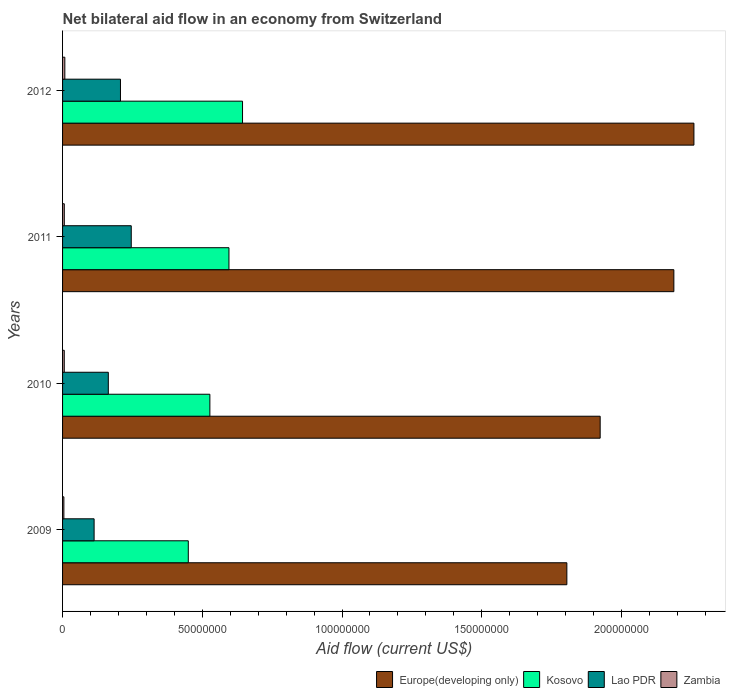How many groups of bars are there?
Your answer should be very brief. 4. Are the number of bars per tick equal to the number of legend labels?
Provide a short and direct response. Yes. How many bars are there on the 4th tick from the top?
Your response must be concise. 4. In how many cases, is the number of bars for a given year not equal to the number of legend labels?
Offer a terse response. 0. What is the net bilateral aid flow in Lao PDR in 2012?
Make the answer very short. 2.07e+07. Across all years, what is the maximum net bilateral aid flow in Europe(developing only)?
Give a very brief answer. 2.26e+08. Across all years, what is the minimum net bilateral aid flow in Zambia?
Provide a short and direct response. 4.70e+05. In which year was the net bilateral aid flow in Lao PDR maximum?
Your answer should be compact. 2011. In which year was the net bilateral aid flow in Europe(developing only) minimum?
Give a very brief answer. 2009. What is the total net bilateral aid flow in Lao PDR in the graph?
Make the answer very short. 7.30e+07. What is the difference between the net bilateral aid flow in Zambia in 2009 and that in 2010?
Ensure brevity in your answer.  -1.40e+05. What is the difference between the net bilateral aid flow in Lao PDR in 2009 and the net bilateral aid flow in Kosovo in 2012?
Provide a short and direct response. -5.31e+07. What is the average net bilateral aid flow in Kosovo per year?
Offer a very short reply. 5.54e+07. In the year 2010, what is the difference between the net bilateral aid flow in Kosovo and net bilateral aid flow in Zambia?
Keep it short and to the point. 5.21e+07. In how many years, is the net bilateral aid flow in Zambia greater than 60000000 US$?
Your answer should be very brief. 0. What is the ratio of the net bilateral aid flow in Zambia in 2009 to that in 2012?
Ensure brevity in your answer.  0.58. What is the difference between the highest and the second highest net bilateral aid flow in Zambia?
Your response must be concise. 1.90e+05. What is the difference between the highest and the lowest net bilateral aid flow in Europe(developing only)?
Ensure brevity in your answer.  4.55e+07. What does the 1st bar from the top in 2012 represents?
Provide a succinct answer. Zambia. What does the 1st bar from the bottom in 2012 represents?
Provide a short and direct response. Europe(developing only). How many years are there in the graph?
Offer a terse response. 4. Are the values on the major ticks of X-axis written in scientific E-notation?
Ensure brevity in your answer.  No. Does the graph contain grids?
Make the answer very short. No. Where does the legend appear in the graph?
Ensure brevity in your answer.  Bottom right. How many legend labels are there?
Provide a short and direct response. 4. How are the legend labels stacked?
Your response must be concise. Horizontal. What is the title of the graph?
Keep it short and to the point. Net bilateral aid flow in an economy from Switzerland. Does "Comoros" appear as one of the legend labels in the graph?
Ensure brevity in your answer.  No. What is the label or title of the X-axis?
Keep it short and to the point. Aid flow (current US$). What is the label or title of the Y-axis?
Ensure brevity in your answer.  Years. What is the Aid flow (current US$) of Europe(developing only) in 2009?
Provide a succinct answer. 1.80e+08. What is the Aid flow (current US$) in Kosovo in 2009?
Provide a succinct answer. 4.50e+07. What is the Aid flow (current US$) in Lao PDR in 2009?
Ensure brevity in your answer.  1.13e+07. What is the Aid flow (current US$) in Zambia in 2009?
Your answer should be compact. 4.70e+05. What is the Aid flow (current US$) in Europe(developing only) in 2010?
Your response must be concise. 1.92e+08. What is the Aid flow (current US$) in Kosovo in 2010?
Provide a succinct answer. 5.27e+07. What is the Aid flow (current US$) in Lao PDR in 2010?
Your answer should be compact. 1.64e+07. What is the Aid flow (current US$) of Zambia in 2010?
Your answer should be compact. 6.10e+05. What is the Aid flow (current US$) in Europe(developing only) in 2011?
Provide a short and direct response. 2.19e+08. What is the Aid flow (current US$) of Kosovo in 2011?
Make the answer very short. 5.95e+07. What is the Aid flow (current US$) of Lao PDR in 2011?
Your answer should be very brief. 2.46e+07. What is the Aid flow (current US$) of Zambia in 2011?
Make the answer very short. 6.20e+05. What is the Aid flow (current US$) of Europe(developing only) in 2012?
Offer a very short reply. 2.26e+08. What is the Aid flow (current US$) of Kosovo in 2012?
Provide a short and direct response. 6.44e+07. What is the Aid flow (current US$) in Lao PDR in 2012?
Provide a short and direct response. 2.07e+07. What is the Aid flow (current US$) in Zambia in 2012?
Offer a very short reply. 8.10e+05. Across all years, what is the maximum Aid flow (current US$) of Europe(developing only)?
Your response must be concise. 2.26e+08. Across all years, what is the maximum Aid flow (current US$) in Kosovo?
Keep it short and to the point. 6.44e+07. Across all years, what is the maximum Aid flow (current US$) in Lao PDR?
Give a very brief answer. 2.46e+07. Across all years, what is the maximum Aid flow (current US$) of Zambia?
Provide a succinct answer. 8.10e+05. Across all years, what is the minimum Aid flow (current US$) of Europe(developing only)?
Make the answer very short. 1.80e+08. Across all years, what is the minimum Aid flow (current US$) in Kosovo?
Your response must be concise. 4.50e+07. Across all years, what is the minimum Aid flow (current US$) in Lao PDR?
Your answer should be compact. 1.13e+07. Across all years, what is the minimum Aid flow (current US$) of Zambia?
Your answer should be compact. 4.70e+05. What is the total Aid flow (current US$) in Europe(developing only) in the graph?
Your answer should be compact. 8.17e+08. What is the total Aid flow (current US$) of Kosovo in the graph?
Your answer should be very brief. 2.22e+08. What is the total Aid flow (current US$) in Lao PDR in the graph?
Give a very brief answer. 7.30e+07. What is the total Aid flow (current US$) in Zambia in the graph?
Provide a succinct answer. 2.51e+06. What is the difference between the Aid flow (current US$) in Europe(developing only) in 2009 and that in 2010?
Provide a succinct answer. -1.19e+07. What is the difference between the Aid flow (current US$) in Kosovo in 2009 and that in 2010?
Your answer should be very brief. -7.72e+06. What is the difference between the Aid flow (current US$) of Lao PDR in 2009 and that in 2010?
Give a very brief answer. -5.08e+06. What is the difference between the Aid flow (current US$) of Europe(developing only) in 2009 and that in 2011?
Provide a succinct answer. -3.83e+07. What is the difference between the Aid flow (current US$) in Kosovo in 2009 and that in 2011?
Provide a succinct answer. -1.46e+07. What is the difference between the Aid flow (current US$) in Lao PDR in 2009 and that in 2011?
Ensure brevity in your answer.  -1.33e+07. What is the difference between the Aid flow (current US$) of Europe(developing only) in 2009 and that in 2012?
Offer a terse response. -4.55e+07. What is the difference between the Aid flow (current US$) of Kosovo in 2009 and that in 2012?
Give a very brief answer. -1.94e+07. What is the difference between the Aid flow (current US$) in Lao PDR in 2009 and that in 2012?
Offer a terse response. -9.43e+06. What is the difference between the Aid flow (current US$) of Europe(developing only) in 2010 and that in 2011?
Offer a very short reply. -2.64e+07. What is the difference between the Aid flow (current US$) of Kosovo in 2010 and that in 2011?
Provide a succinct answer. -6.83e+06. What is the difference between the Aid flow (current US$) of Lao PDR in 2010 and that in 2011?
Give a very brief answer. -8.21e+06. What is the difference between the Aid flow (current US$) in Europe(developing only) in 2010 and that in 2012?
Offer a terse response. -3.36e+07. What is the difference between the Aid flow (current US$) of Kosovo in 2010 and that in 2012?
Keep it short and to the point. -1.17e+07. What is the difference between the Aid flow (current US$) in Lao PDR in 2010 and that in 2012?
Your answer should be compact. -4.35e+06. What is the difference between the Aid flow (current US$) of Zambia in 2010 and that in 2012?
Offer a very short reply. -2.00e+05. What is the difference between the Aid flow (current US$) in Europe(developing only) in 2011 and that in 2012?
Your answer should be compact. -7.18e+06. What is the difference between the Aid flow (current US$) in Kosovo in 2011 and that in 2012?
Provide a succinct answer. -4.86e+06. What is the difference between the Aid flow (current US$) of Lao PDR in 2011 and that in 2012?
Make the answer very short. 3.86e+06. What is the difference between the Aid flow (current US$) of Europe(developing only) in 2009 and the Aid flow (current US$) of Kosovo in 2010?
Offer a very short reply. 1.28e+08. What is the difference between the Aid flow (current US$) of Europe(developing only) in 2009 and the Aid flow (current US$) of Lao PDR in 2010?
Offer a very short reply. 1.64e+08. What is the difference between the Aid flow (current US$) of Europe(developing only) in 2009 and the Aid flow (current US$) of Zambia in 2010?
Keep it short and to the point. 1.80e+08. What is the difference between the Aid flow (current US$) in Kosovo in 2009 and the Aid flow (current US$) in Lao PDR in 2010?
Your answer should be very brief. 2.86e+07. What is the difference between the Aid flow (current US$) of Kosovo in 2009 and the Aid flow (current US$) of Zambia in 2010?
Your answer should be very brief. 4.44e+07. What is the difference between the Aid flow (current US$) of Lao PDR in 2009 and the Aid flow (current US$) of Zambia in 2010?
Keep it short and to the point. 1.07e+07. What is the difference between the Aid flow (current US$) in Europe(developing only) in 2009 and the Aid flow (current US$) in Kosovo in 2011?
Offer a very short reply. 1.21e+08. What is the difference between the Aid flow (current US$) of Europe(developing only) in 2009 and the Aid flow (current US$) of Lao PDR in 2011?
Ensure brevity in your answer.  1.56e+08. What is the difference between the Aid flow (current US$) in Europe(developing only) in 2009 and the Aid flow (current US$) in Zambia in 2011?
Provide a short and direct response. 1.80e+08. What is the difference between the Aid flow (current US$) of Kosovo in 2009 and the Aid flow (current US$) of Lao PDR in 2011?
Give a very brief answer. 2.04e+07. What is the difference between the Aid flow (current US$) in Kosovo in 2009 and the Aid flow (current US$) in Zambia in 2011?
Give a very brief answer. 4.44e+07. What is the difference between the Aid flow (current US$) in Lao PDR in 2009 and the Aid flow (current US$) in Zambia in 2011?
Ensure brevity in your answer.  1.07e+07. What is the difference between the Aid flow (current US$) in Europe(developing only) in 2009 and the Aid flow (current US$) in Kosovo in 2012?
Ensure brevity in your answer.  1.16e+08. What is the difference between the Aid flow (current US$) of Europe(developing only) in 2009 and the Aid flow (current US$) of Lao PDR in 2012?
Your answer should be compact. 1.60e+08. What is the difference between the Aid flow (current US$) of Europe(developing only) in 2009 and the Aid flow (current US$) of Zambia in 2012?
Provide a short and direct response. 1.80e+08. What is the difference between the Aid flow (current US$) in Kosovo in 2009 and the Aid flow (current US$) in Lao PDR in 2012?
Offer a very short reply. 2.43e+07. What is the difference between the Aid flow (current US$) in Kosovo in 2009 and the Aid flow (current US$) in Zambia in 2012?
Your answer should be compact. 4.42e+07. What is the difference between the Aid flow (current US$) of Lao PDR in 2009 and the Aid flow (current US$) of Zambia in 2012?
Your answer should be very brief. 1.05e+07. What is the difference between the Aid flow (current US$) in Europe(developing only) in 2010 and the Aid flow (current US$) in Kosovo in 2011?
Your answer should be compact. 1.33e+08. What is the difference between the Aid flow (current US$) in Europe(developing only) in 2010 and the Aid flow (current US$) in Lao PDR in 2011?
Keep it short and to the point. 1.68e+08. What is the difference between the Aid flow (current US$) in Europe(developing only) in 2010 and the Aid flow (current US$) in Zambia in 2011?
Provide a succinct answer. 1.92e+08. What is the difference between the Aid flow (current US$) of Kosovo in 2010 and the Aid flow (current US$) of Lao PDR in 2011?
Offer a terse response. 2.81e+07. What is the difference between the Aid flow (current US$) in Kosovo in 2010 and the Aid flow (current US$) in Zambia in 2011?
Provide a succinct answer. 5.21e+07. What is the difference between the Aid flow (current US$) in Lao PDR in 2010 and the Aid flow (current US$) in Zambia in 2011?
Make the answer very short. 1.58e+07. What is the difference between the Aid flow (current US$) in Europe(developing only) in 2010 and the Aid flow (current US$) in Kosovo in 2012?
Ensure brevity in your answer.  1.28e+08. What is the difference between the Aid flow (current US$) of Europe(developing only) in 2010 and the Aid flow (current US$) of Lao PDR in 2012?
Your response must be concise. 1.72e+08. What is the difference between the Aid flow (current US$) of Europe(developing only) in 2010 and the Aid flow (current US$) of Zambia in 2012?
Offer a terse response. 1.92e+08. What is the difference between the Aid flow (current US$) of Kosovo in 2010 and the Aid flow (current US$) of Lao PDR in 2012?
Give a very brief answer. 3.20e+07. What is the difference between the Aid flow (current US$) of Kosovo in 2010 and the Aid flow (current US$) of Zambia in 2012?
Offer a very short reply. 5.19e+07. What is the difference between the Aid flow (current US$) in Lao PDR in 2010 and the Aid flow (current US$) in Zambia in 2012?
Your response must be concise. 1.56e+07. What is the difference between the Aid flow (current US$) in Europe(developing only) in 2011 and the Aid flow (current US$) in Kosovo in 2012?
Your answer should be compact. 1.54e+08. What is the difference between the Aid flow (current US$) of Europe(developing only) in 2011 and the Aid flow (current US$) of Lao PDR in 2012?
Your response must be concise. 1.98e+08. What is the difference between the Aid flow (current US$) of Europe(developing only) in 2011 and the Aid flow (current US$) of Zambia in 2012?
Your response must be concise. 2.18e+08. What is the difference between the Aid flow (current US$) of Kosovo in 2011 and the Aid flow (current US$) of Lao PDR in 2012?
Provide a short and direct response. 3.88e+07. What is the difference between the Aid flow (current US$) in Kosovo in 2011 and the Aid flow (current US$) in Zambia in 2012?
Provide a succinct answer. 5.87e+07. What is the difference between the Aid flow (current US$) of Lao PDR in 2011 and the Aid flow (current US$) of Zambia in 2012?
Your response must be concise. 2.38e+07. What is the average Aid flow (current US$) in Europe(developing only) per year?
Your answer should be compact. 2.04e+08. What is the average Aid flow (current US$) in Kosovo per year?
Provide a succinct answer. 5.54e+07. What is the average Aid flow (current US$) in Lao PDR per year?
Provide a succinct answer. 1.82e+07. What is the average Aid flow (current US$) of Zambia per year?
Offer a very short reply. 6.28e+05. In the year 2009, what is the difference between the Aid flow (current US$) of Europe(developing only) and Aid flow (current US$) of Kosovo?
Make the answer very short. 1.35e+08. In the year 2009, what is the difference between the Aid flow (current US$) of Europe(developing only) and Aid flow (current US$) of Lao PDR?
Provide a short and direct response. 1.69e+08. In the year 2009, what is the difference between the Aid flow (current US$) of Europe(developing only) and Aid flow (current US$) of Zambia?
Offer a very short reply. 1.80e+08. In the year 2009, what is the difference between the Aid flow (current US$) of Kosovo and Aid flow (current US$) of Lao PDR?
Offer a very short reply. 3.37e+07. In the year 2009, what is the difference between the Aid flow (current US$) in Kosovo and Aid flow (current US$) in Zambia?
Ensure brevity in your answer.  4.45e+07. In the year 2009, what is the difference between the Aid flow (current US$) in Lao PDR and Aid flow (current US$) in Zambia?
Your answer should be compact. 1.08e+07. In the year 2010, what is the difference between the Aid flow (current US$) of Europe(developing only) and Aid flow (current US$) of Kosovo?
Make the answer very short. 1.40e+08. In the year 2010, what is the difference between the Aid flow (current US$) in Europe(developing only) and Aid flow (current US$) in Lao PDR?
Your answer should be compact. 1.76e+08. In the year 2010, what is the difference between the Aid flow (current US$) of Europe(developing only) and Aid flow (current US$) of Zambia?
Provide a short and direct response. 1.92e+08. In the year 2010, what is the difference between the Aid flow (current US$) of Kosovo and Aid flow (current US$) of Lao PDR?
Offer a terse response. 3.63e+07. In the year 2010, what is the difference between the Aid flow (current US$) of Kosovo and Aid flow (current US$) of Zambia?
Give a very brief answer. 5.21e+07. In the year 2010, what is the difference between the Aid flow (current US$) in Lao PDR and Aid flow (current US$) in Zambia?
Your answer should be very brief. 1.58e+07. In the year 2011, what is the difference between the Aid flow (current US$) of Europe(developing only) and Aid flow (current US$) of Kosovo?
Give a very brief answer. 1.59e+08. In the year 2011, what is the difference between the Aid flow (current US$) in Europe(developing only) and Aid flow (current US$) in Lao PDR?
Your answer should be very brief. 1.94e+08. In the year 2011, what is the difference between the Aid flow (current US$) in Europe(developing only) and Aid flow (current US$) in Zambia?
Your answer should be very brief. 2.18e+08. In the year 2011, what is the difference between the Aid flow (current US$) in Kosovo and Aid flow (current US$) in Lao PDR?
Make the answer very short. 3.50e+07. In the year 2011, what is the difference between the Aid flow (current US$) of Kosovo and Aid flow (current US$) of Zambia?
Your answer should be compact. 5.89e+07. In the year 2011, what is the difference between the Aid flow (current US$) in Lao PDR and Aid flow (current US$) in Zambia?
Offer a very short reply. 2.40e+07. In the year 2012, what is the difference between the Aid flow (current US$) of Europe(developing only) and Aid flow (current US$) of Kosovo?
Offer a terse response. 1.62e+08. In the year 2012, what is the difference between the Aid flow (current US$) in Europe(developing only) and Aid flow (current US$) in Lao PDR?
Ensure brevity in your answer.  2.05e+08. In the year 2012, what is the difference between the Aid flow (current US$) of Europe(developing only) and Aid flow (current US$) of Zambia?
Ensure brevity in your answer.  2.25e+08. In the year 2012, what is the difference between the Aid flow (current US$) in Kosovo and Aid flow (current US$) in Lao PDR?
Your answer should be compact. 4.37e+07. In the year 2012, what is the difference between the Aid flow (current US$) of Kosovo and Aid flow (current US$) of Zambia?
Give a very brief answer. 6.36e+07. In the year 2012, what is the difference between the Aid flow (current US$) in Lao PDR and Aid flow (current US$) in Zambia?
Provide a succinct answer. 1.99e+07. What is the ratio of the Aid flow (current US$) in Europe(developing only) in 2009 to that in 2010?
Keep it short and to the point. 0.94. What is the ratio of the Aid flow (current US$) in Kosovo in 2009 to that in 2010?
Ensure brevity in your answer.  0.85. What is the ratio of the Aid flow (current US$) of Lao PDR in 2009 to that in 2010?
Your response must be concise. 0.69. What is the ratio of the Aid flow (current US$) of Zambia in 2009 to that in 2010?
Keep it short and to the point. 0.77. What is the ratio of the Aid flow (current US$) of Europe(developing only) in 2009 to that in 2011?
Offer a very short reply. 0.82. What is the ratio of the Aid flow (current US$) in Kosovo in 2009 to that in 2011?
Your answer should be very brief. 0.76. What is the ratio of the Aid flow (current US$) in Lao PDR in 2009 to that in 2011?
Ensure brevity in your answer.  0.46. What is the ratio of the Aid flow (current US$) of Zambia in 2009 to that in 2011?
Ensure brevity in your answer.  0.76. What is the ratio of the Aid flow (current US$) of Europe(developing only) in 2009 to that in 2012?
Ensure brevity in your answer.  0.8. What is the ratio of the Aid flow (current US$) of Kosovo in 2009 to that in 2012?
Provide a short and direct response. 0.7. What is the ratio of the Aid flow (current US$) in Lao PDR in 2009 to that in 2012?
Your answer should be compact. 0.54. What is the ratio of the Aid flow (current US$) in Zambia in 2009 to that in 2012?
Keep it short and to the point. 0.58. What is the ratio of the Aid flow (current US$) in Europe(developing only) in 2010 to that in 2011?
Ensure brevity in your answer.  0.88. What is the ratio of the Aid flow (current US$) of Kosovo in 2010 to that in 2011?
Offer a very short reply. 0.89. What is the ratio of the Aid flow (current US$) of Lao PDR in 2010 to that in 2011?
Your answer should be very brief. 0.67. What is the ratio of the Aid flow (current US$) in Zambia in 2010 to that in 2011?
Provide a succinct answer. 0.98. What is the ratio of the Aid flow (current US$) of Europe(developing only) in 2010 to that in 2012?
Keep it short and to the point. 0.85. What is the ratio of the Aid flow (current US$) in Kosovo in 2010 to that in 2012?
Provide a succinct answer. 0.82. What is the ratio of the Aid flow (current US$) in Lao PDR in 2010 to that in 2012?
Provide a short and direct response. 0.79. What is the ratio of the Aid flow (current US$) in Zambia in 2010 to that in 2012?
Make the answer very short. 0.75. What is the ratio of the Aid flow (current US$) of Europe(developing only) in 2011 to that in 2012?
Ensure brevity in your answer.  0.97. What is the ratio of the Aid flow (current US$) in Kosovo in 2011 to that in 2012?
Ensure brevity in your answer.  0.92. What is the ratio of the Aid flow (current US$) of Lao PDR in 2011 to that in 2012?
Your response must be concise. 1.19. What is the ratio of the Aid flow (current US$) of Zambia in 2011 to that in 2012?
Give a very brief answer. 0.77. What is the difference between the highest and the second highest Aid flow (current US$) in Europe(developing only)?
Ensure brevity in your answer.  7.18e+06. What is the difference between the highest and the second highest Aid flow (current US$) of Kosovo?
Ensure brevity in your answer.  4.86e+06. What is the difference between the highest and the second highest Aid flow (current US$) in Lao PDR?
Ensure brevity in your answer.  3.86e+06. What is the difference between the highest and the lowest Aid flow (current US$) of Europe(developing only)?
Your response must be concise. 4.55e+07. What is the difference between the highest and the lowest Aid flow (current US$) in Kosovo?
Your response must be concise. 1.94e+07. What is the difference between the highest and the lowest Aid flow (current US$) in Lao PDR?
Provide a succinct answer. 1.33e+07. 